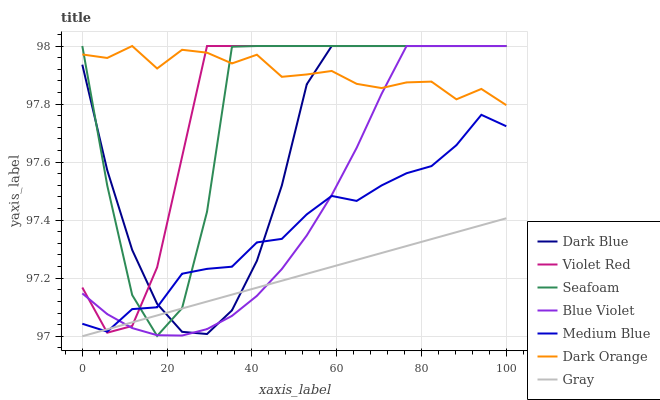Does Gray have the minimum area under the curve?
Answer yes or no. Yes. Does Dark Orange have the maximum area under the curve?
Answer yes or no. Yes. Does Violet Red have the minimum area under the curve?
Answer yes or no. No. Does Violet Red have the maximum area under the curve?
Answer yes or no. No. Is Gray the smoothest?
Answer yes or no. Yes. Is Seafoam the roughest?
Answer yes or no. Yes. Is Violet Red the smoothest?
Answer yes or no. No. Is Violet Red the roughest?
Answer yes or no. No. Does Gray have the lowest value?
Answer yes or no. Yes. Does Violet Red have the lowest value?
Answer yes or no. No. Does Blue Violet have the highest value?
Answer yes or no. Yes. Does Gray have the highest value?
Answer yes or no. No. Is Gray less than Dark Orange?
Answer yes or no. Yes. Is Dark Orange greater than Gray?
Answer yes or no. Yes. Does Medium Blue intersect Gray?
Answer yes or no. Yes. Is Medium Blue less than Gray?
Answer yes or no. No. Is Medium Blue greater than Gray?
Answer yes or no. No. Does Gray intersect Dark Orange?
Answer yes or no. No. 